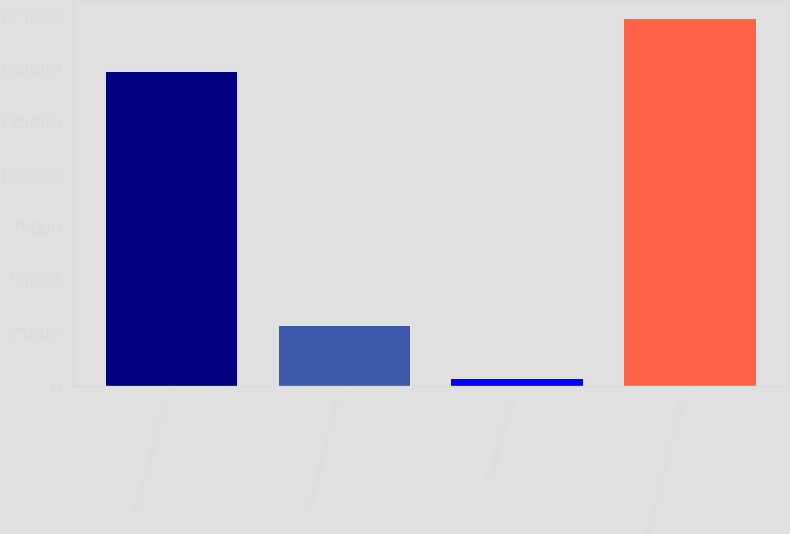Convert chart. <chart><loc_0><loc_0><loc_500><loc_500><bar_chart><fcel>Balance January 1 2012<fcel>Actual return on assets<fcel>Transfers in (out)<fcel>Balance December 31 2012<nl><fcel>148574<fcel>28420<fcel>3369<fcel>173625<nl></chart> 